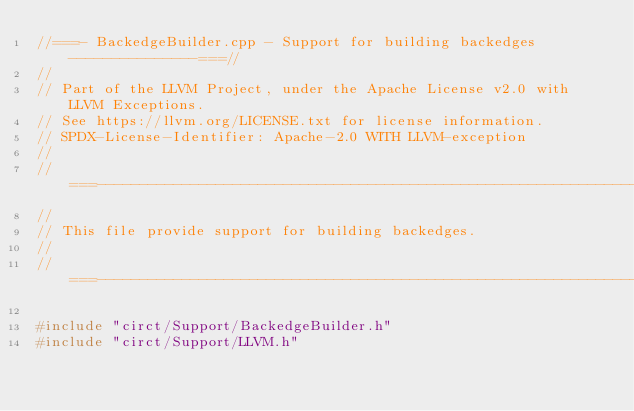Convert code to text. <code><loc_0><loc_0><loc_500><loc_500><_C++_>//===- BackedgeBuilder.cpp - Support for building backedges ---------------===//
//
// Part of the LLVM Project, under the Apache License v2.0 with LLVM Exceptions.
// See https://llvm.org/LICENSE.txt for license information.
// SPDX-License-Identifier: Apache-2.0 WITH LLVM-exception
//
//===----------------------------------------------------------------------===//
//
// This file provide support for building backedges.
//
//===----------------------------------------------------------------------===//

#include "circt/Support/BackedgeBuilder.h"
#include "circt/Support/LLVM.h"
</code> 